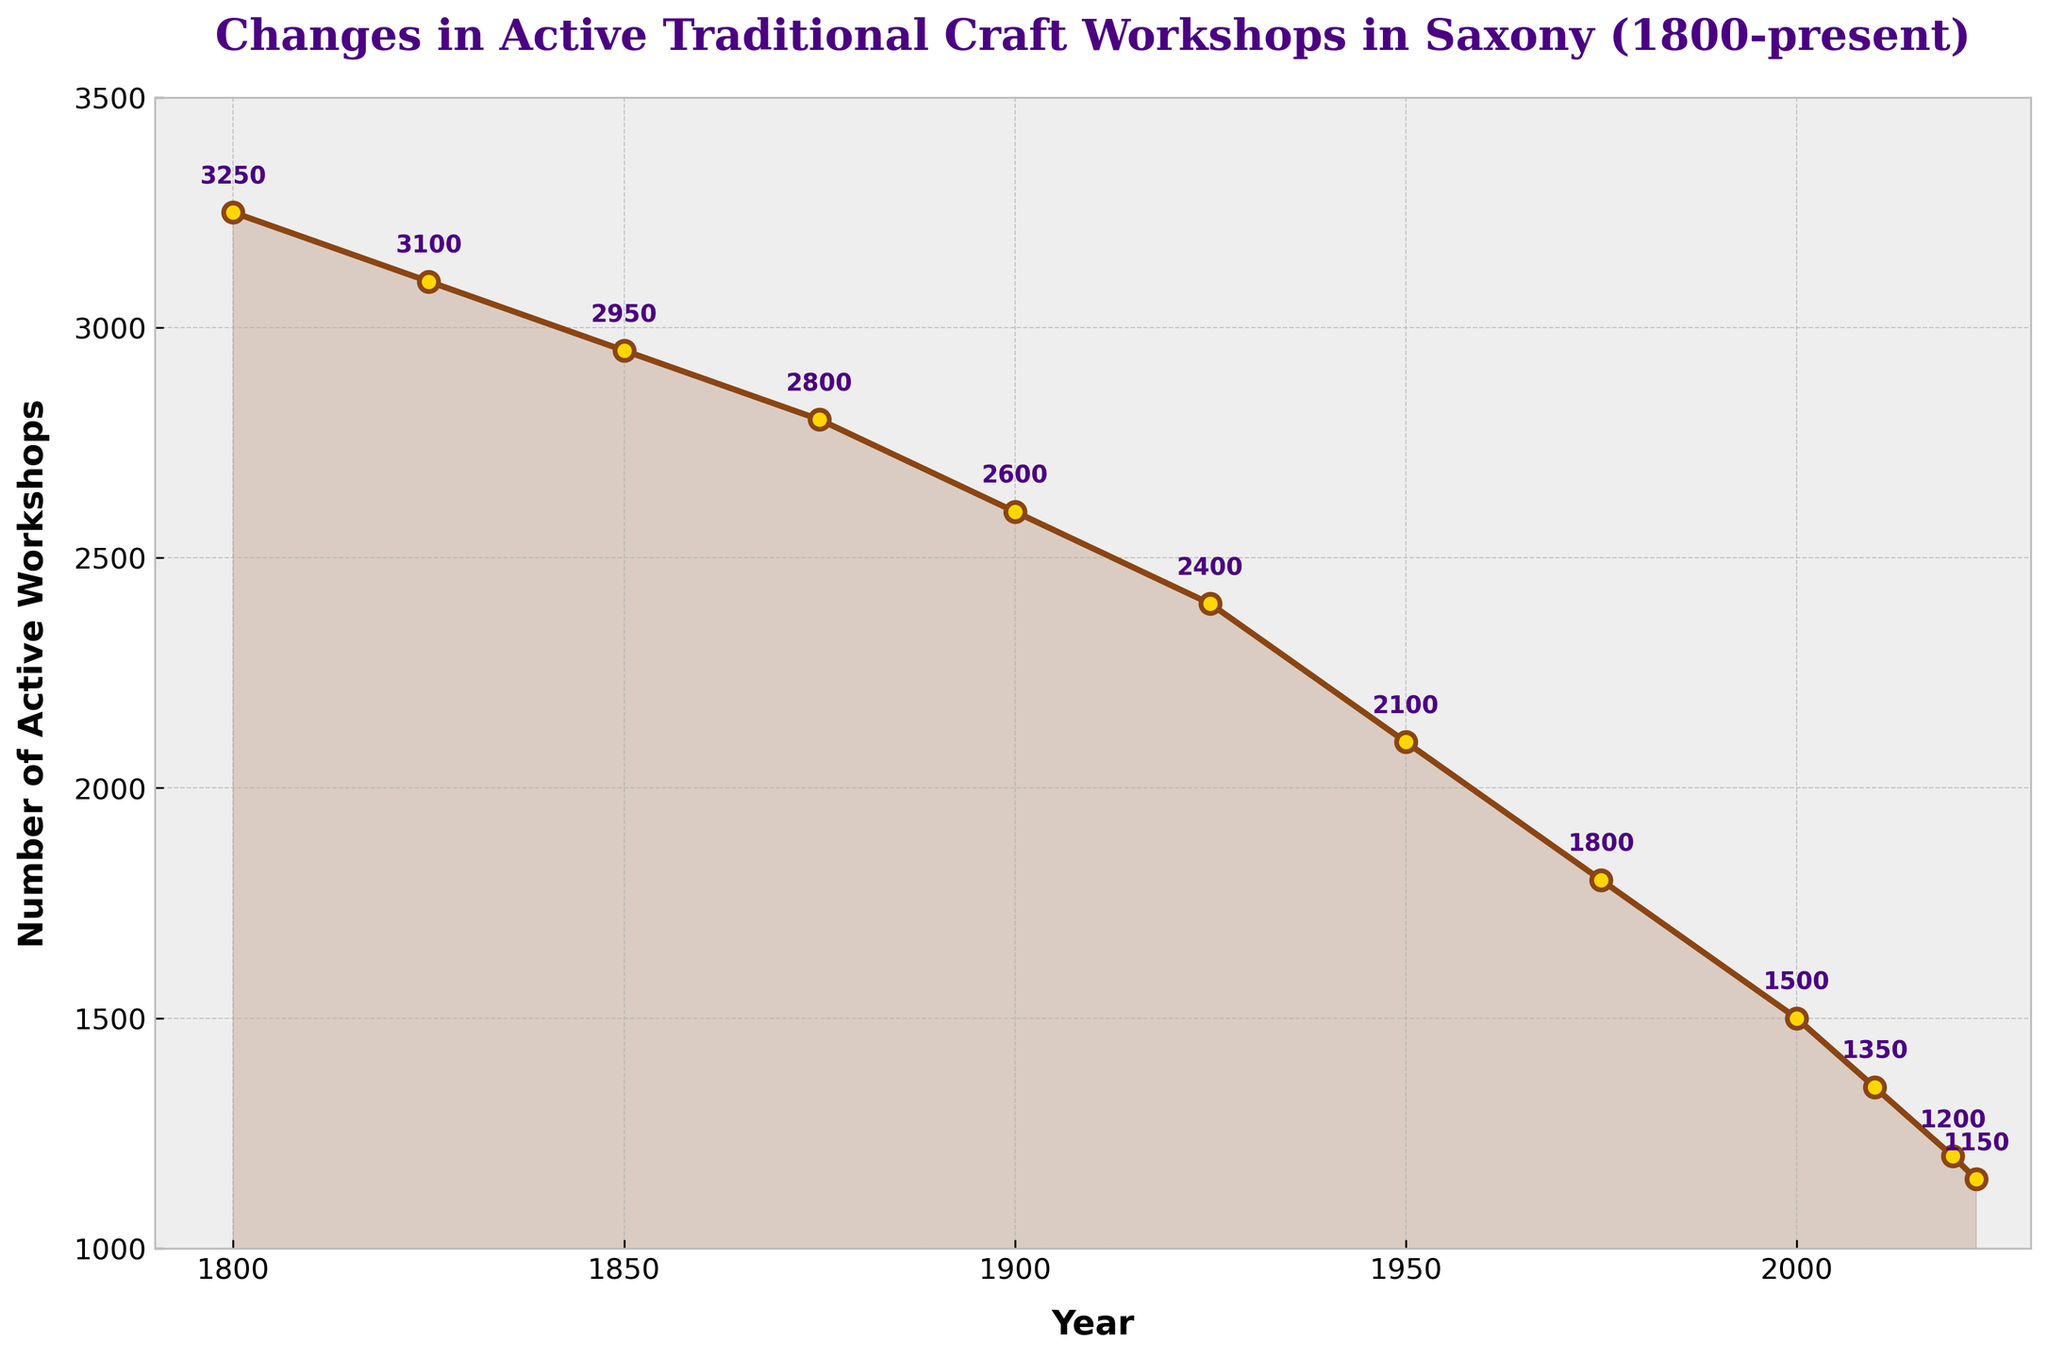How many active traditional craft workshops were there in 1950? Find the data point for the year 1950, which is 2100
Answer: 2100 What is the difference in the number of active workshops between 1800 and 2000? Subtract the number of workshops in 2000 (1500) from the number in 1800 (3250): 3250 - 1500 = 1750
Answer: 1750 Which year had more active traditional craft workshops, 1825 or 1875? Compare the number of workshops in 1825 (3100) with that in 1875 (2800). 1825 had more.
Answer: 1825 What is the average number of active workshops from 2000 to 2023? Sum the numbers for the years 2000, 2010, 2020, and 2023: 1500 + 1350 + 1200 + 1150 = 5200. Divide by the number of years: 5200 / 4 = 1300
Answer: 1300 In which year was the decline in the number of workshops the largest compared to the previous data point? Calculate the differences for each interval: 1800-1825: 3250-3100=150, 1825-1850: 3100-2950=150, 1850-1875: 2950-2800=150, 1875-1900: 2800-2600=200, 1900-1925: 2600-2400=200, 1925-1950: 2400-2100=300, 1950-1975: 2100-1800=300, 1975-2000: 1800-1500=300, 2000-2010: 1500-1350=150, 2010-2020: 1350-1200=150, 2020-2023: 1200-1150=50. The largest decline is in any of the 1925-1950, 1950-1975, or 1975-2000 intervals.
Answer: 1925-2000 Around what year did the number of workshops fall below 2000? Find the year in the plot where the number of workshops goes below 2000. It is just before 1975.
Answer: 1975 What is the median number of active workshops for the given years? Arrange the numbers: 1150, 1200, 1350, 1500, 1800, 2100, 2400, 2600, 2800, 2950, 3100, 3250. The median is the average of the 6th and 7th values: (2100 + 2400) / 2 = 2250
Answer: 2250 How has the overall trend in the number of workshops changed from 1800 to 2023? Observe the plot from left to right and note that the line generally slopes downward, indicating a consistent decline.
Answer: Decline 